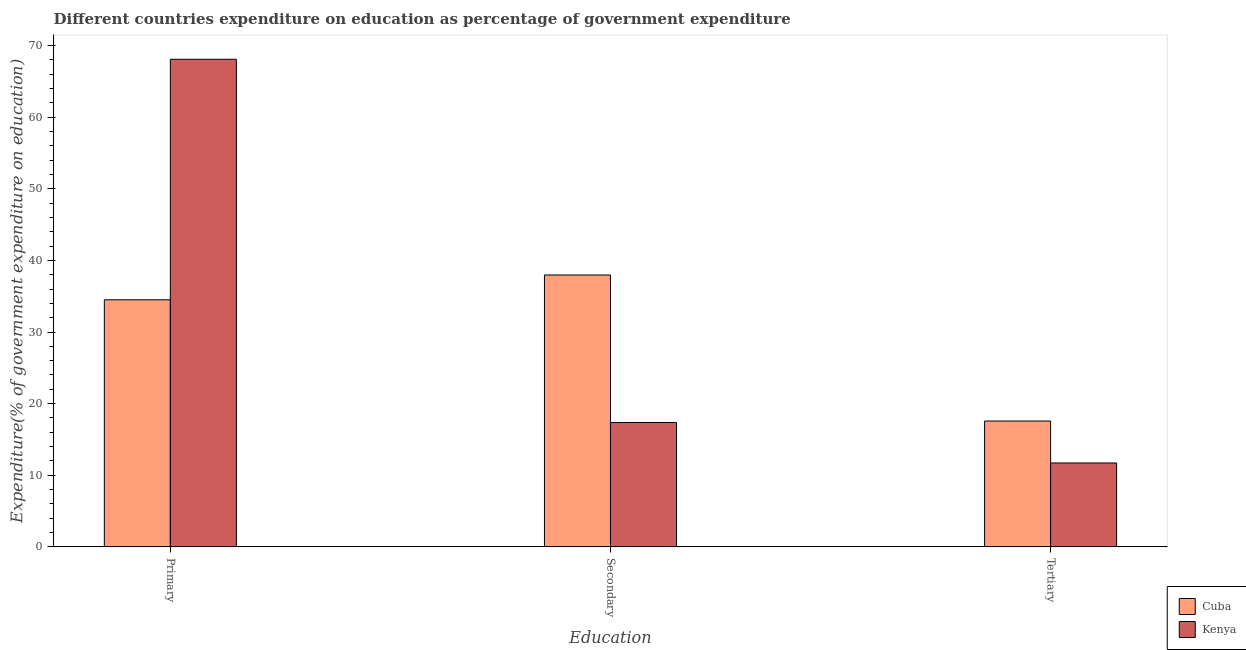How many different coloured bars are there?
Your response must be concise. 2. What is the label of the 2nd group of bars from the left?
Provide a succinct answer. Secondary. What is the expenditure on primary education in Kenya?
Make the answer very short. 68.09. Across all countries, what is the maximum expenditure on tertiary education?
Your response must be concise. 17.57. Across all countries, what is the minimum expenditure on tertiary education?
Your answer should be very brief. 11.71. In which country was the expenditure on secondary education maximum?
Offer a terse response. Cuba. In which country was the expenditure on secondary education minimum?
Make the answer very short. Kenya. What is the total expenditure on primary education in the graph?
Your answer should be very brief. 102.59. What is the difference between the expenditure on tertiary education in Cuba and that in Kenya?
Keep it short and to the point. 5.86. What is the difference between the expenditure on tertiary education in Kenya and the expenditure on primary education in Cuba?
Ensure brevity in your answer.  -22.79. What is the average expenditure on secondary education per country?
Provide a short and direct response. 27.66. What is the difference between the expenditure on secondary education and expenditure on primary education in Cuba?
Make the answer very short. 3.46. What is the ratio of the expenditure on primary education in Cuba to that in Kenya?
Your response must be concise. 0.51. What is the difference between the highest and the second highest expenditure on secondary education?
Provide a short and direct response. 20.6. What is the difference between the highest and the lowest expenditure on secondary education?
Provide a short and direct response. 20.6. What does the 2nd bar from the left in Tertiary represents?
Ensure brevity in your answer.  Kenya. What does the 2nd bar from the right in Secondary represents?
Give a very brief answer. Cuba. Is it the case that in every country, the sum of the expenditure on primary education and expenditure on secondary education is greater than the expenditure on tertiary education?
Your answer should be very brief. Yes. How many bars are there?
Provide a short and direct response. 6. Are all the bars in the graph horizontal?
Provide a succinct answer. No. Are the values on the major ticks of Y-axis written in scientific E-notation?
Your answer should be very brief. No. Does the graph contain any zero values?
Ensure brevity in your answer.  No. How many legend labels are there?
Make the answer very short. 2. How are the legend labels stacked?
Provide a short and direct response. Vertical. What is the title of the graph?
Offer a very short reply. Different countries expenditure on education as percentage of government expenditure. Does "Mali" appear as one of the legend labels in the graph?
Make the answer very short. No. What is the label or title of the X-axis?
Give a very brief answer. Education. What is the label or title of the Y-axis?
Provide a short and direct response. Expenditure(% of government expenditure on education). What is the Expenditure(% of government expenditure on education) in Cuba in Primary?
Your response must be concise. 34.5. What is the Expenditure(% of government expenditure on education) in Kenya in Primary?
Your response must be concise. 68.09. What is the Expenditure(% of government expenditure on education) of Cuba in Secondary?
Provide a short and direct response. 37.96. What is the Expenditure(% of government expenditure on education) of Kenya in Secondary?
Give a very brief answer. 17.36. What is the Expenditure(% of government expenditure on education) in Cuba in Tertiary?
Your answer should be very brief. 17.57. What is the Expenditure(% of government expenditure on education) of Kenya in Tertiary?
Offer a terse response. 11.71. Across all Education, what is the maximum Expenditure(% of government expenditure on education) of Cuba?
Your answer should be very brief. 37.96. Across all Education, what is the maximum Expenditure(% of government expenditure on education) of Kenya?
Keep it short and to the point. 68.09. Across all Education, what is the minimum Expenditure(% of government expenditure on education) of Cuba?
Provide a short and direct response. 17.57. Across all Education, what is the minimum Expenditure(% of government expenditure on education) in Kenya?
Your answer should be compact. 11.71. What is the total Expenditure(% of government expenditure on education) of Cuba in the graph?
Provide a short and direct response. 90.03. What is the total Expenditure(% of government expenditure on education) in Kenya in the graph?
Your response must be concise. 97.16. What is the difference between the Expenditure(% of government expenditure on education) of Cuba in Primary and that in Secondary?
Ensure brevity in your answer.  -3.46. What is the difference between the Expenditure(% of government expenditure on education) of Kenya in Primary and that in Secondary?
Ensure brevity in your answer.  50.73. What is the difference between the Expenditure(% of government expenditure on education) of Cuba in Primary and that in Tertiary?
Your answer should be very brief. 16.93. What is the difference between the Expenditure(% of government expenditure on education) of Kenya in Primary and that in Tertiary?
Your answer should be compact. 56.38. What is the difference between the Expenditure(% of government expenditure on education) of Cuba in Secondary and that in Tertiary?
Keep it short and to the point. 20.39. What is the difference between the Expenditure(% of government expenditure on education) in Kenya in Secondary and that in Tertiary?
Your answer should be very brief. 5.65. What is the difference between the Expenditure(% of government expenditure on education) in Cuba in Primary and the Expenditure(% of government expenditure on education) in Kenya in Secondary?
Your answer should be very brief. 17.14. What is the difference between the Expenditure(% of government expenditure on education) in Cuba in Primary and the Expenditure(% of government expenditure on education) in Kenya in Tertiary?
Provide a succinct answer. 22.79. What is the difference between the Expenditure(% of government expenditure on education) in Cuba in Secondary and the Expenditure(% of government expenditure on education) in Kenya in Tertiary?
Offer a terse response. 26.25. What is the average Expenditure(% of government expenditure on education) of Cuba per Education?
Ensure brevity in your answer.  30.01. What is the average Expenditure(% of government expenditure on education) of Kenya per Education?
Offer a very short reply. 32.39. What is the difference between the Expenditure(% of government expenditure on education) in Cuba and Expenditure(% of government expenditure on education) in Kenya in Primary?
Ensure brevity in your answer.  -33.59. What is the difference between the Expenditure(% of government expenditure on education) of Cuba and Expenditure(% of government expenditure on education) of Kenya in Secondary?
Provide a short and direct response. 20.6. What is the difference between the Expenditure(% of government expenditure on education) of Cuba and Expenditure(% of government expenditure on education) of Kenya in Tertiary?
Your response must be concise. 5.86. What is the ratio of the Expenditure(% of government expenditure on education) of Cuba in Primary to that in Secondary?
Make the answer very short. 0.91. What is the ratio of the Expenditure(% of government expenditure on education) of Kenya in Primary to that in Secondary?
Your answer should be compact. 3.92. What is the ratio of the Expenditure(% of government expenditure on education) in Cuba in Primary to that in Tertiary?
Make the answer very short. 1.96. What is the ratio of the Expenditure(% of government expenditure on education) of Kenya in Primary to that in Tertiary?
Your answer should be very brief. 5.81. What is the ratio of the Expenditure(% of government expenditure on education) in Cuba in Secondary to that in Tertiary?
Make the answer very short. 2.16. What is the ratio of the Expenditure(% of government expenditure on education) in Kenya in Secondary to that in Tertiary?
Offer a terse response. 1.48. What is the difference between the highest and the second highest Expenditure(% of government expenditure on education) in Cuba?
Your response must be concise. 3.46. What is the difference between the highest and the second highest Expenditure(% of government expenditure on education) in Kenya?
Keep it short and to the point. 50.73. What is the difference between the highest and the lowest Expenditure(% of government expenditure on education) in Cuba?
Provide a succinct answer. 20.39. What is the difference between the highest and the lowest Expenditure(% of government expenditure on education) in Kenya?
Your answer should be compact. 56.38. 